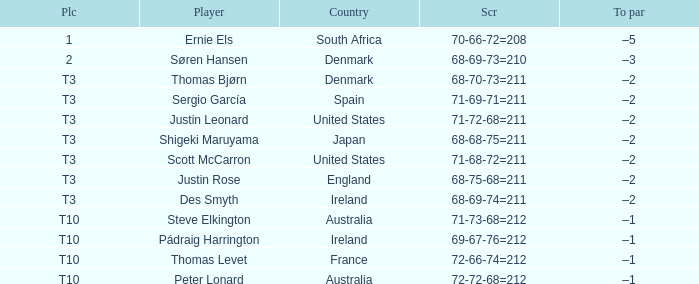What was Australia's score when Peter Lonard played? 72-72-68=212. 